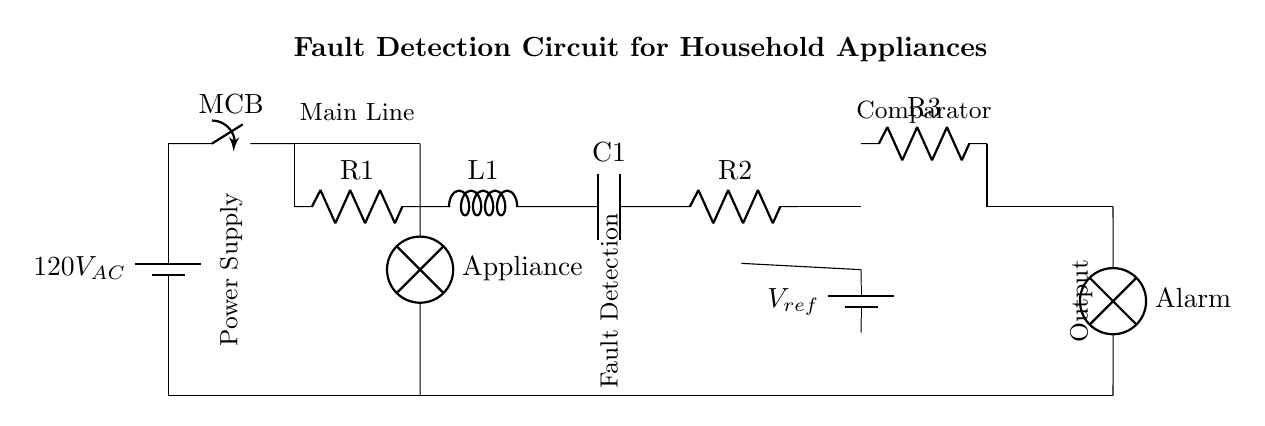What is the input voltage to the circuit? The input voltage is specified as 120V AC, which can be identified from the battery symbol at the top of the diagram.
Answer: 120V AC What components make up the fault detection circuit? The fault detection circuit includes R1, L1, C1, R2, and R3, which are listed in sequence between the main circuit breaker and the comparator.
Answer: R1, L1, C1, R2, R3 What is the purpose of the comparator in this circuit? The comparator is used to compare the voltage across R2 with the reference voltage from V ref, determining if a fault exists based on their relationship.
Answer: Fault detection How many resistors are in the circuit? There are three resistors present in the circuit diagram, identified as R1, R2, and R3.
Answer: Three What is the output of the circuit connected to? The output of the circuit is connected to an alarm, indicating a fault condition when triggered by the comparator.
Answer: Alarm Why is the reference voltage important in this circuit? The reference voltage serves as a benchmark for the comparator, allowing it to determine if the voltage indicates normal operation or a fault, thereby preventing malfunctioning appliances.
Answer: Benchmark for comparison What does the term MCB stand for in this context? MCB stands for Miniature Circuit Breaker, which is a safety device that automatically switches off the circuit in case of an overload or fault condition.
Answer: Miniature Circuit Breaker 